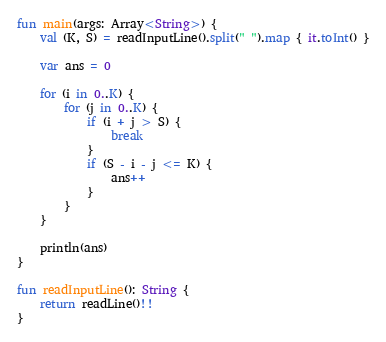Convert code to text. <code><loc_0><loc_0><loc_500><loc_500><_Kotlin_>fun main(args: Array<String>) {
    val (K, S) = readInputLine().split(" ").map { it.toInt() }

    var ans = 0

    for (i in 0..K) {
        for (j in 0..K) {
            if (i + j > S) {
                break
            }
            if (S - i - j <= K) {
                ans++
            }
        }
    }

    println(ans)
}

fun readInputLine(): String {
    return readLine()!!
}
</code> 